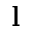<formula> <loc_0><loc_0><loc_500><loc_500>l</formula> 